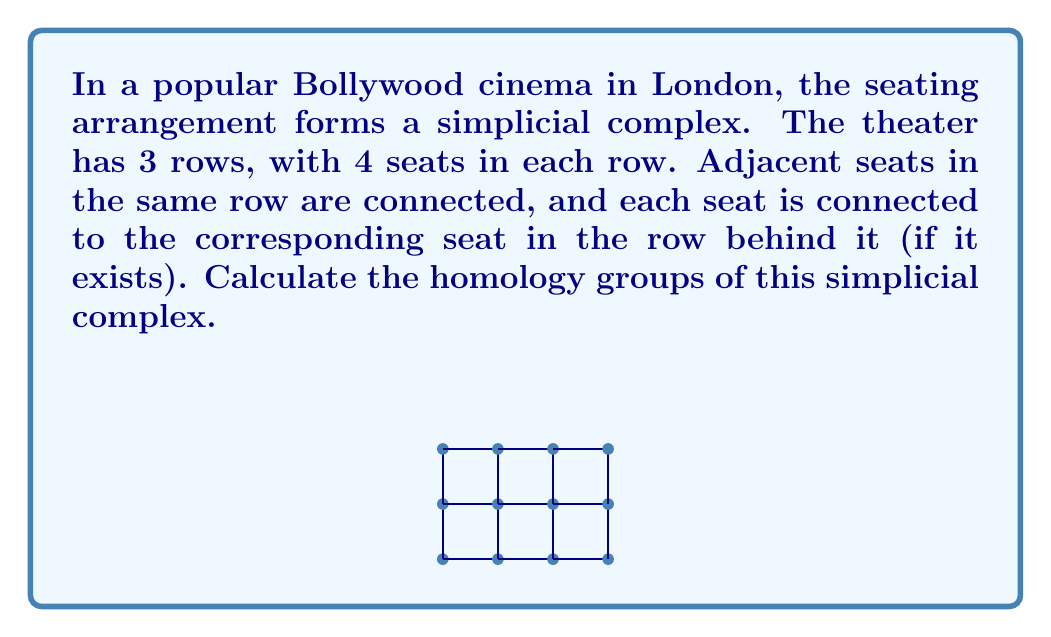Could you help me with this problem? Let's approach this step-by-step:

1) First, we need to count the simplices in each dimension:
   - 0-simplices (vertices): 12
   - 1-simplices (edges): 29 (11 horizontal + 18 vertical)
   - 2-simplices (triangles): 18

2) Now, let's calculate the boundary maps:
   $$\partial_2: C_2 \to C_1, \partial_1: C_1 \to C_0$$

3) We can represent these maps as matrices. The rank of these matrices will be important:
   - rank($\partial_2$) = 18 (full rank, as each triangle has a unique boundary)
   - rank($\partial_1$) = 11 (the number of independent cycles)

4) Now we can calculate the Betti numbers:
   - $b_0 = \dim(\ker \partial_0) - \text{rank}(\partial_1) = 12 - 11 = 1$
   - $b_1 = \dim(\ker \partial_1) - \text{rank}(\partial_2) = (29 - 11) - 18 = 0$
   - $b_2 = \dim(\ker \partial_2) = 0$ (since $\partial_2$ has full rank)

5) The homology groups are:
   - $H_0 \cong \mathbb{Z}$ (the complex is connected)
   - $H_1 \cong 0$ (no holes)
   - $H_2 \cong 0$ (no voids)

6) Therefore, the homology groups are $H_0 \cong \mathbb{Z}, H_1 \cong 0, H_2 \cong 0$.
Answer: $H_0 \cong \mathbb{Z}, H_1 \cong 0, H_2 \cong 0$ 